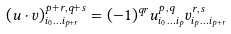Convert formula to latex. <formula><loc_0><loc_0><loc_500><loc_500>( u \cdot v ) ^ { p + r , q + s } _ { i _ { 0 } \dots i _ { p + r } } = ( - 1 ) ^ { q r } u ^ { p , q } _ { i _ { 0 } \dots i _ { p } } v ^ { r , s } _ { i _ { p } \dots i _ { p + r } }</formula> 